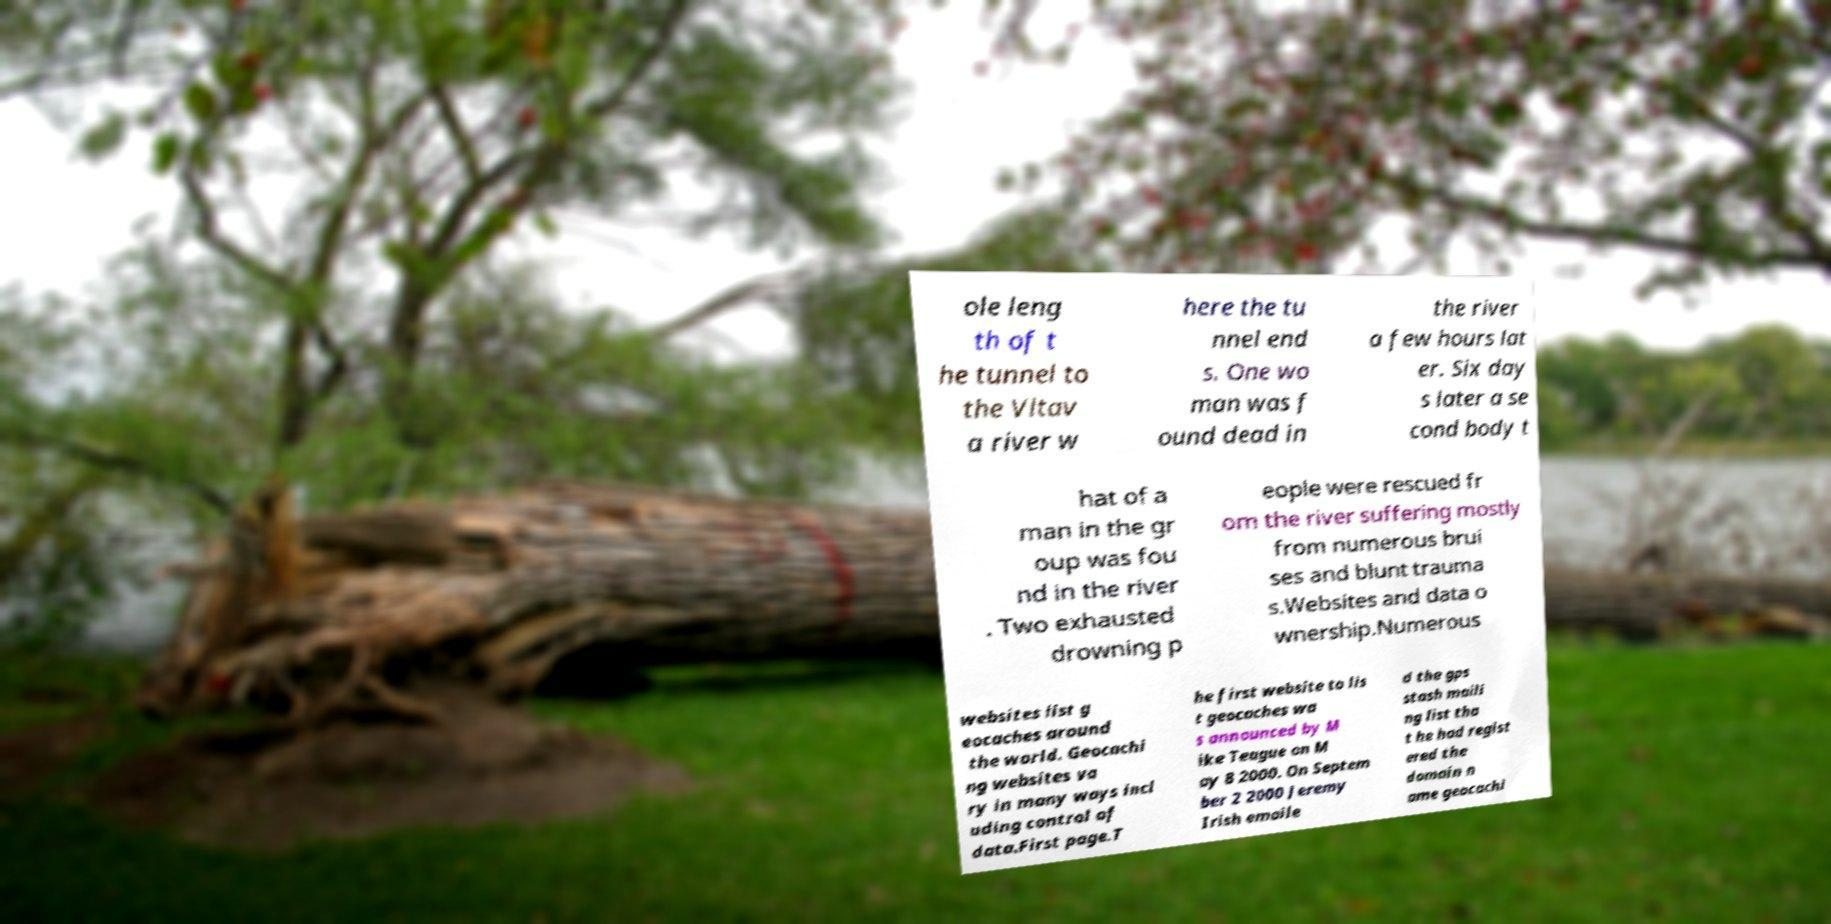Could you assist in decoding the text presented in this image and type it out clearly? ole leng th of t he tunnel to the Vltav a river w here the tu nnel end s. One wo man was f ound dead in the river a few hours lat er. Six day s later a se cond body t hat of a man in the gr oup was fou nd in the river . Two exhausted drowning p eople were rescued fr om the river suffering mostly from numerous brui ses and blunt trauma s.Websites and data o wnership.Numerous websites list g eocaches around the world. Geocachi ng websites va ry in many ways incl uding control of data.First page.T he first website to lis t geocaches wa s announced by M ike Teague on M ay 8 2000. On Septem ber 2 2000 Jeremy Irish emaile d the gps stash maili ng list tha t he had regist ered the domain n ame geocachi 